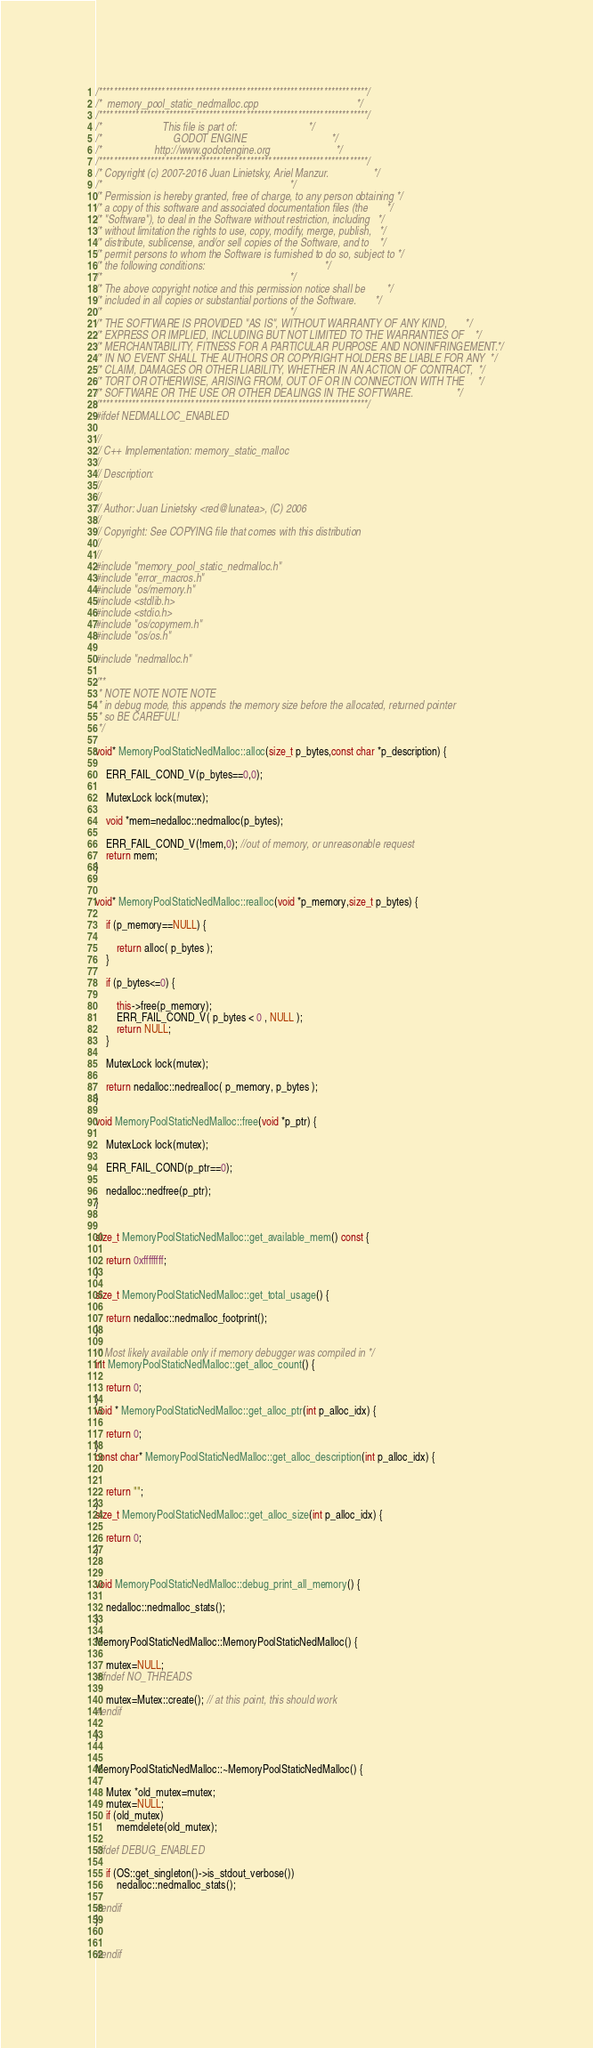<code> <loc_0><loc_0><loc_500><loc_500><_C++_>/*************************************************************************/
/*  memory_pool_static_nedmalloc.cpp                                     */
/*************************************************************************/
/*                       This file is part of:                           */
/*                           GODOT ENGINE                                */
/*                    http://www.godotengine.org                         */
/*************************************************************************/
/* Copyright (c) 2007-2016 Juan Linietsky, Ariel Manzur.                 */
/*                                                                       */
/* Permission is hereby granted, free of charge, to any person obtaining */
/* a copy of this software and associated documentation files (the       */
/* "Software"), to deal in the Software without restriction, including   */
/* without limitation the rights to use, copy, modify, merge, publish,   */
/* distribute, sublicense, and/or sell copies of the Software, and to    */
/* permit persons to whom the Software is furnished to do so, subject to */
/* the following conditions:                                             */
/*                                                                       */
/* The above copyright notice and this permission notice shall be        */
/* included in all copies or substantial portions of the Software.       */
/*                                                                       */
/* THE SOFTWARE IS PROVIDED "AS IS", WITHOUT WARRANTY OF ANY KIND,       */
/* EXPRESS OR IMPLIED, INCLUDING BUT NOT LIMITED TO THE WARRANTIES OF    */
/* MERCHANTABILITY, FITNESS FOR A PARTICULAR PURPOSE AND NONINFRINGEMENT.*/
/* IN NO EVENT SHALL THE AUTHORS OR COPYRIGHT HOLDERS BE LIABLE FOR ANY  */
/* CLAIM, DAMAGES OR OTHER LIABILITY, WHETHER IN AN ACTION OF CONTRACT,  */
/* TORT OR OTHERWISE, ARISING FROM, OUT OF OR IN CONNECTION WITH THE     */
/* SOFTWARE OR THE USE OR OTHER DEALINGS IN THE SOFTWARE.                */
/*************************************************************************/
#ifdef NEDMALLOC_ENABLED

//
// C++ Implementation: memory_static_malloc
//
// Description: 
//
//
// Author: Juan Linietsky <red@lunatea>, (C) 2006
//
// Copyright: See COPYING file that comes with this distribution
//
//
#include "memory_pool_static_nedmalloc.h"
#include "error_macros.h"
#include "os/memory.h"
#include <stdlib.h>
#include <stdio.h>
#include "os/copymem.h"
#include "os/os.h"

#include "nedmalloc.h"

/**
 * NOTE NOTE NOTE NOTE
 * in debug mode, this appends the memory size before the allocated, returned pointer
 * so BE CAREFUL!
 */

void* MemoryPoolStaticNedMalloc::alloc(size_t p_bytes,const char *p_description) {

 	ERR_FAIL_COND_V(p_bytes==0,0);

	MutexLock lock(mutex);

	void *mem=nedalloc::nedmalloc(p_bytes);

	ERR_FAIL_COND_V(!mem,0); //out of memory, or unreasonable request
	return mem;			
}


void* MemoryPoolStaticNedMalloc::realloc(void *p_memory,size_t p_bytes) {
	
	if (p_memory==NULL) {
		
		return alloc( p_bytes );
	}
		
	if (p_bytes<=0) {
		
		this->free(p_memory);
		ERR_FAIL_COND_V( p_bytes < 0 , NULL );
		return NULL;
	}
	
	MutexLock lock(mutex);

	return nedalloc::nedrealloc( p_memory, p_bytes );
}

void MemoryPoolStaticNedMalloc::free(void *p_ptr) {
	
	MutexLock lock(mutex);
	
	ERR_FAIL_COND(p_ptr==0);

	nedalloc::nedfree(p_ptr);
}


size_t MemoryPoolStaticNedMalloc::get_available_mem() const {

	return 0xffffffff;
}

size_t MemoryPoolStaticNedMalloc::get_total_usage() {

	return nedalloc::nedmalloc_footprint();
}
			
/* Most likely available only if memory debugger was compiled in */
int MemoryPoolStaticNedMalloc::get_alloc_count() {
	
	return 0;
}
void * MemoryPoolStaticNedMalloc::get_alloc_ptr(int p_alloc_idx) {
	
	return 0;
}
const char* MemoryPoolStaticNedMalloc::get_alloc_description(int p_alloc_idx) {
	
	
	return "";
}
size_t MemoryPoolStaticNedMalloc::get_alloc_size(int p_alloc_idx) {
	
	return 0;
}


void MemoryPoolStaticNedMalloc::debug_print_all_memory() {

	nedalloc::nedmalloc_stats();
}

MemoryPoolStaticNedMalloc::MemoryPoolStaticNedMalloc() {
	
	mutex=NULL;
#ifndef NO_THREADS

	mutex=Mutex::create(); // at this point, this should work
#endif

}


MemoryPoolStaticNedMalloc::~MemoryPoolStaticNedMalloc() {
	
	Mutex *old_mutex=mutex;
	mutex=NULL;
	if (old_mutex)
		memdelete(old_mutex);
	
#ifdef DEBUG_ENABLED

	if (OS::get_singleton()->is_stdout_verbose())
		nedalloc::nedmalloc_stats();

#endif
}


#endif

</code> 